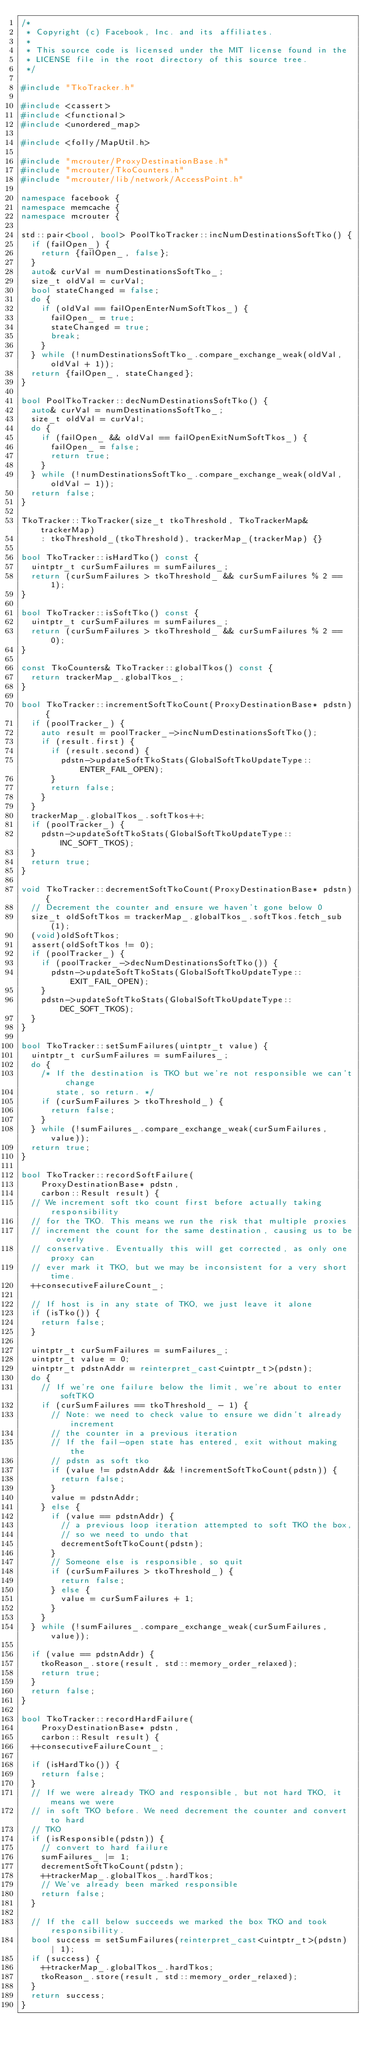Convert code to text. <code><loc_0><loc_0><loc_500><loc_500><_C++_>/*
 * Copyright (c) Facebook, Inc. and its affiliates.
 *
 * This source code is licensed under the MIT license found in the
 * LICENSE file in the root directory of this source tree.
 */

#include "TkoTracker.h"

#include <cassert>
#include <functional>
#include <unordered_map>

#include <folly/MapUtil.h>

#include "mcrouter/ProxyDestinationBase.h"
#include "mcrouter/TkoCounters.h"
#include "mcrouter/lib/network/AccessPoint.h"

namespace facebook {
namespace memcache {
namespace mcrouter {

std::pair<bool, bool> PoolTkoTracker::incNumDestinationsSoftTko() {
  if (failOpen_) {
    return {failOpen_, false};
  }
  auto& curVal = numDestinationsSoftTko_;
  size_t oldVal = curVal;
  bool stateChanged = false;
  do {
    if (oldVal == failOpenEnterNumSoftTkos_) {
      failOpen_ = true;
      stateChanged = true;
      break;
    }
  } while (!numDestinationsSoftTko_.compare_exchange_weak(oldVal, oldVal + 1));
  return {failOpen_, stateChanged};
}

bool PoolTkoTracker::decNumDestinationsSoftTko() {
  auto& curVal = numDestinationsSoftTko_;
  size_t oldVal = curVal;
  do {
    if (failOpen_ && oldVal == failOpenExitNumSoftTkos_) {
      failOpen_ = false;
      return true;
    }
  } while (!numDestinationsSoftTko_.compare_exchange_weak(oldVal, oldVal - 1));
  return false;
}

TkoTracker::TkoTracker(size_t tkoThreshold, TkoTrackerMap& trackerMap)
    : tkoThreshold_(tkoThreshold), trackerMap_(trackerMap) {}

bool TkoTracker::isHardTko() const {
  uintptr_t curSumFailures = sumFailures_;
  return (curSumFailures > tkoThreshold_ && curSumFailures % 2 == 1);
}

bool TkoTracker::isSoftTko() const {
  uintptr_t curSumFailures = sumFailures_;
  return (curSumFailures > tkoThreshold_ && curSumFailures % 2 == 0);
}

const TkoCounters& TkoTracker::globalTkos() const {
  return trackerMap_.globalTkos_;
}

bool TkoTracker::incrementSoftTkoCount(ProxyDestinationBase* pdstn) {
  if (poolTracker_) {
    auto result = poolTracker_->incNumDestinationsSoftTko();
    if (result.first) {
      if (result.second) {
        pdstn->updateSoftTkoStats(GlobalSoftTkoUpdateType::ENTER_FAIL_OPEN);
      }
      return false;
    }
  }
  trackerMap_.globalTkos_.softTkos++;
  if (poolTracker_) {
    pdstn->updateSoftTkoStats(GlobalSoftTkoUpdateType::INC_SOFT_TKOS);
  }
  return true;
}

void TkoTracker::decrementSoftTkoCount(ProxyDestinationBase* pdstn) {
  // Decrement the counter and ensure we haven't gone below 0
  size_t oldSoftTkos = trackerMap_.globalTkos_.softTkos.fetch_sub(1);
  (void)oldSoftTkos;
  assert(oldSoftTkos != 0);
  if (poolTracker_) {
    if (poolTracker_->decNumDestinationsSoftTko()) {
      pdstn->updateSoftTkoStats(GlobalSoftTkoUpdateType::EXIT_FAIL_OPEN);
    }
    pdstn->updateSoftTkoStats(GlobalSoftTkoUpdateType::DEC_SOFT_TKOS);
  }
}

bool TkoTracker::setSumFailures(uintptr_t value) {
  uintptr_t curSumFailures = sumFailures_;
  do {
    /* If the destination is TKO but we're not responsible we can't change
       state, so return. */
    if (curSumFailures > tkoThreshold_) {
      return false;
    }
  } while (!sumFailures_.compare_exchange_weak(curSumFailures, value));
  return true;
}

bool TkoTracker::recordSoftFailure(
    ProxyDestinationBase* pdstn,
    carbon::Result result) {
  // We increment soft tko count first before actually taking responsibility
  // for the TKO. This means we run the risk that multiple proxies
  // increment the count for the same destination, causing us to be overly
  // conservative. Eventually this will get corrected, as only one proxy can
  // ever mark it TKO, but we may be inconsistent for a very short time.
  ++consecutiveFailureCount_;

  // If host is in any state of TKO, we just leave it alone
  if (isTko()) {
    return false;
  }

  uintptr_t curSumFailures = sumFailures_;
  uintptr_t value = 0;
  uintptr_t pdstnAddr = reinterpret_cast<uintptr_t>(pdstn);
  do {
    // If we're one failure below the limit, we're about to enter softTKO
    if (curSumFailures == tkoThreshold_ - 1) {
      // Note: we need to check value to ensure we didn't already increment
      // the counter in a previous iteration
      // If the fail-open state has entered, exit without making the
      // pdstn as soft tko
      if (value != pdstnAddr && !incrementSoftTkoCount(pdstn)) {
        return false;
      }
      value = pdstnAddr;
    } else {
      if (value == pdstnAddr) {
        // a previous loop iteration attempted to soft TKO the box,
        // so we need to undo that
        decrementSoftTkoCount(pdstn);
      }
      // Someone else is responsible, so quit
      if (curSumFailures > tkoThreshold_) {
        return false;
      } else {
        value = curSumFailures + 1;
      }
    }
  } while (!sumFailures_.compare_exchange_weak(curSumFailures, value));

  if (value == pdstnAddr) {
    tkoReason_.store(result, std::memory_order_relaxed);
    return true;
  }
  return false;
}

bool TkoTracker::recordHardFailure(
    ProxyDestinationBase* pdstn,
    carbon::Result result) {
  ++consecutiveFailureCount_;

  if (isHardTko()) {
    return false;
  }
  // If we were already TKO and responsible, but not hard TKO, it means we were
  // in soft TKO before. We need decrement the counter and convert to hard
  // TKO
  if (isResponsible(pdstn)) {
    // convert to hard failure
    sumFailures_ |= 1;
    decrementSoftTkoCount(pdstn);
    ++trackerMap_.globalTkos_.hardTkos;
    // We've already been marked responsible
    return false;
  }

  // If the call below succeeds we marked the box TKO and took responsibility.
  bool success = setSumFailures(reinterpret_cast<uintptr_t>(pdstn) | 1);
  if (success) {
    ++trackerMap_.globalTkos_.hardTkos;
    tkoReason_.store(result, std::memory_order_relaxed);
  }
  return success;
}
</code> 